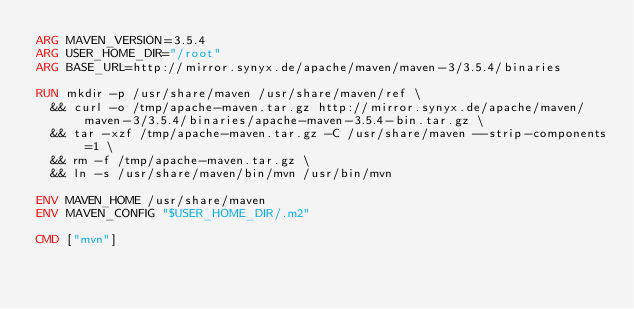Convert code to text. <code><loc_0><loc_0><loc_500><loc_500><_Dockerfile_>ARG MAVEN_VERSION=3.5.4
ARG USER_HOME_DIR="/root"
ARG BASE_URL=http://mirror.synyx.de/apache/maven/maven-3/3.5.4/binaries

RUN mkdir -p /usr/share/maven /usr/share/maven/ref \
  && curl -o /tmp/apache-maven.tar.gz http://mirror.synyx.de/apache/maven/maven-3/3.5.4/binaries/apache-maven-3.5.4-bin.tar.gz \
  && tar -xzf /tmp/apache-maven.tar.gz -C /usr/share/maven --strip-components=1 \
  && rm -f /tmp/apache-maven.tar.gz \
  && ln -s /usr/share/maven/bin/mvn /usr/bin/mvn

ENV MAVEN_HOME /usr/share/maven
ENV MAVEN_CONFIG "$USER_HOME_DIR/.m2"

CMD ["mvn"]</code> 